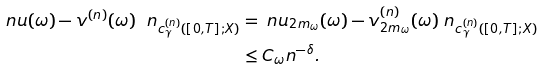Convert formula to latex. <formula><loc_0><loc_0><loc_500><loc_500>\ n u ( \omega ) - v ^ { ( n ) } ( \omega ) \ n _ { c ^ { ( n ) } _ { \gamma } ( [ 0 , T ] ; X ) } & = \ n u _ { 2 m _ { \omega } } ( \omega ) - v _ { 2 m _ { \omega } } ^ { ( n ) } ( \omega ) \ n _ { c ^ { ( n ) } _ { \gamma } ( [ 0 , T ] ; X ) } \\ & \leq C _ { \omega } n ^ { - \delta } .</formula> 